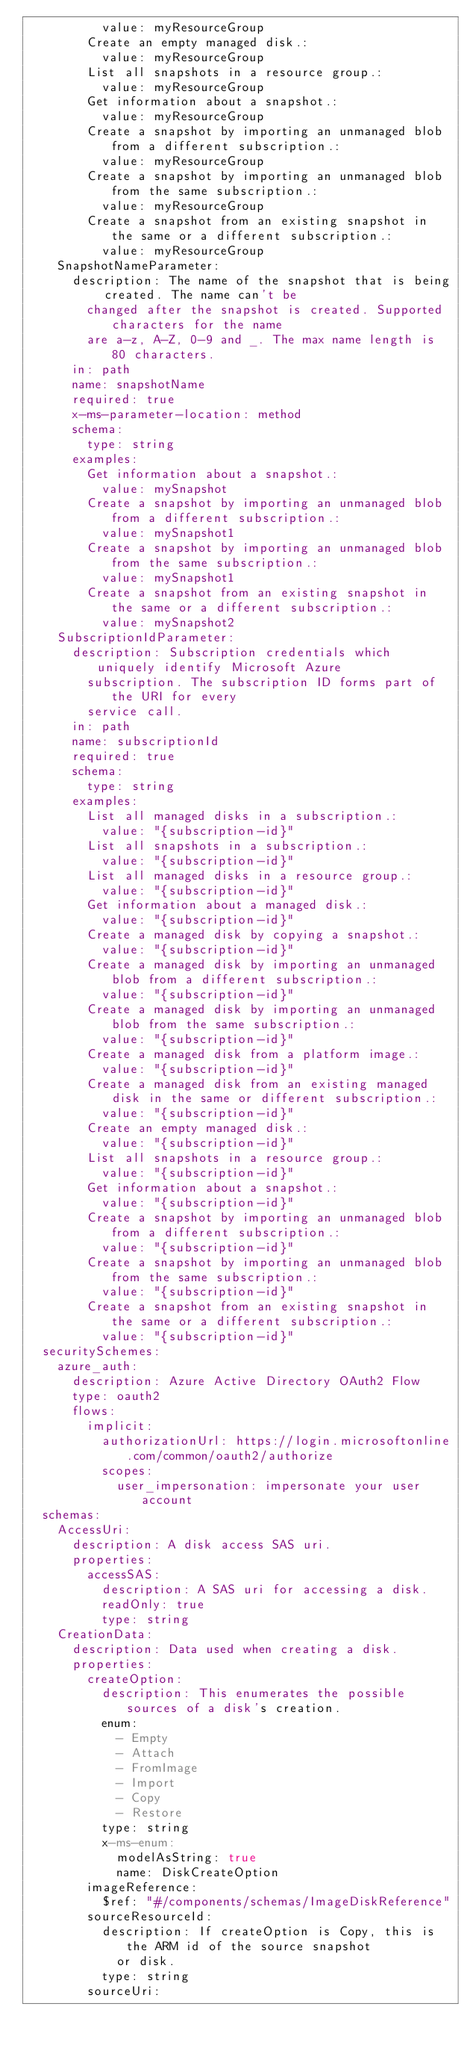<code> <loc_0><loc_0><loc_500><loc_500><_YAML_>          value: myResourceGroup
        Create an empty managed disk.:
          value: myResourceGroup
        List all snapshots in a resource group.:
          value: myResourceGroup
        Get information about a snapshot.:
          value: myResourceGroup
        Create a snapshot by importing an unmanaged blob from a different subscription.:
          value: myResourceGroup
        Create a snapshot by importing an unmanaged blob from the same subscription.:
          value: myResourceGroup
        Create a snapshot from an existing snapshot in the same or a different subscription.:
          value: myResourceGroup
    SnapshotNameParameter:
      description: The name of the snapshot that is being created. The name can't be
        changed after the snapshot is created. Supported characters for the name
        are a-z, A-Z, 0-9 and _. The max name length is 80 characters.
      in: path
      name: snapshotName
      required: true
      x-ms-parameter-location: method
      schema:
        type: string
      examples:
        Get information about a snapshot.:
          value: mySnapshot
        Create a snapshot by importing an unmanaged blob from a different subscription.:
          value: mySnapshot1
        Create a snapshot by importing an unmanaged blob from the same subscription.:
          value: mySnapshot1
        Create a snapshot from an existing snapshot in the same or a different subscription.:
          value: mySnapshot2
    SubscriptionIdParameter:
      description: Subscription credentials which uniquely identify Microsoft Azure
        subscription. The subscription ID forms part of the URI for every
        service call.
      in: path
      name: subscriptionId
      required: true
      schema:
        type: string
      examples:
        List all managed disks in a subscription.:
          value: "{subscription-id}"
        List all snapshots in a subscription.:
          value: "{subscription-id}"
        List all managed disks in a resource group.:
          value: "{subscription-id}"
        Get information about a managed disk.:
          value: "{subscription-id}"
        Create a managed disk by copying a snapshot.:
          value: "{subscription-id}"
        Create a managed disk by importing an unmanaged blob from a different subscription.:
          value: "{subscription-id}"
        Create a managed disk by importing an unmanaged blob from the same subscription.:
          value: "{subscription-id}"
        Create a managed disk from a platform image.:
          value: "{subscription-id}"
        Create a managed disk from an existing managed disk in the same or different subscription.:
          value: "{subscription-id}"
        Create an empty managed disk.:
          value: "{subscription-id}"
        List all snapshots in a resource group.:
          value: "{subscription-id}"
        Get information about a snapshot.:
          value: "{subscription-id}"
        Create a snapshot by importing an unmanaged blob from a different subscription.:
          value: "{subscription-id}"
        Create a snapshot by importing an unmanaged blob from the same subscription.:
          value: "{subscription-id}"
        Create a snapshot from an existing snapshot in the same or a different subscription.:
          value: "{subscription-id}"
  securitySchemes:
    azure_auth:
      description: Azure Active Directory OAuth2 Flow
      type: oauth2
      flows:
        implicit:
          authorizationUrl: https://login.microsoftonline.com/common/oauth2/authorize
          scopes:
            user_impersonation: impersonate your user account
  schemas:
    AccessUri:
      description: A disk access SAS uri.
      properties:
        accessSAS:
          description: A SAS uri for accessing a disk.
          readOnly: true
          type: string
    CreationData:
      description: Data used when creating a disk.
      properties:
        createOption:
          description: This enumerates the possible sources of a disk's creation.
          enum:
            - Empty
            - Attach
            - FromImage
            - Import
            - Copy
            - Restore
          type: string
          x-ms-enum:
            modelAsString: true
            name: DiskCreateOption
        imageReference:
          $ref: "#/components/schemas/ImageDiskReference"
        sourceResourceId:
          description: If createOption is Copy, this is the ARM id of the source snapshot
            or disk.
          type: string
        sourceUri:</code> 